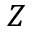<formula> <loc_0><loc_0><loc_500><loc_500>Z</formula> 